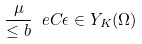Convert formula to latex. <formula><loc_0><loc_0><loc_500><loc_500>\frac { \mu } { \leq b } \ e C \epsilon \in Y _ { K } ( \Omega )</formula> 